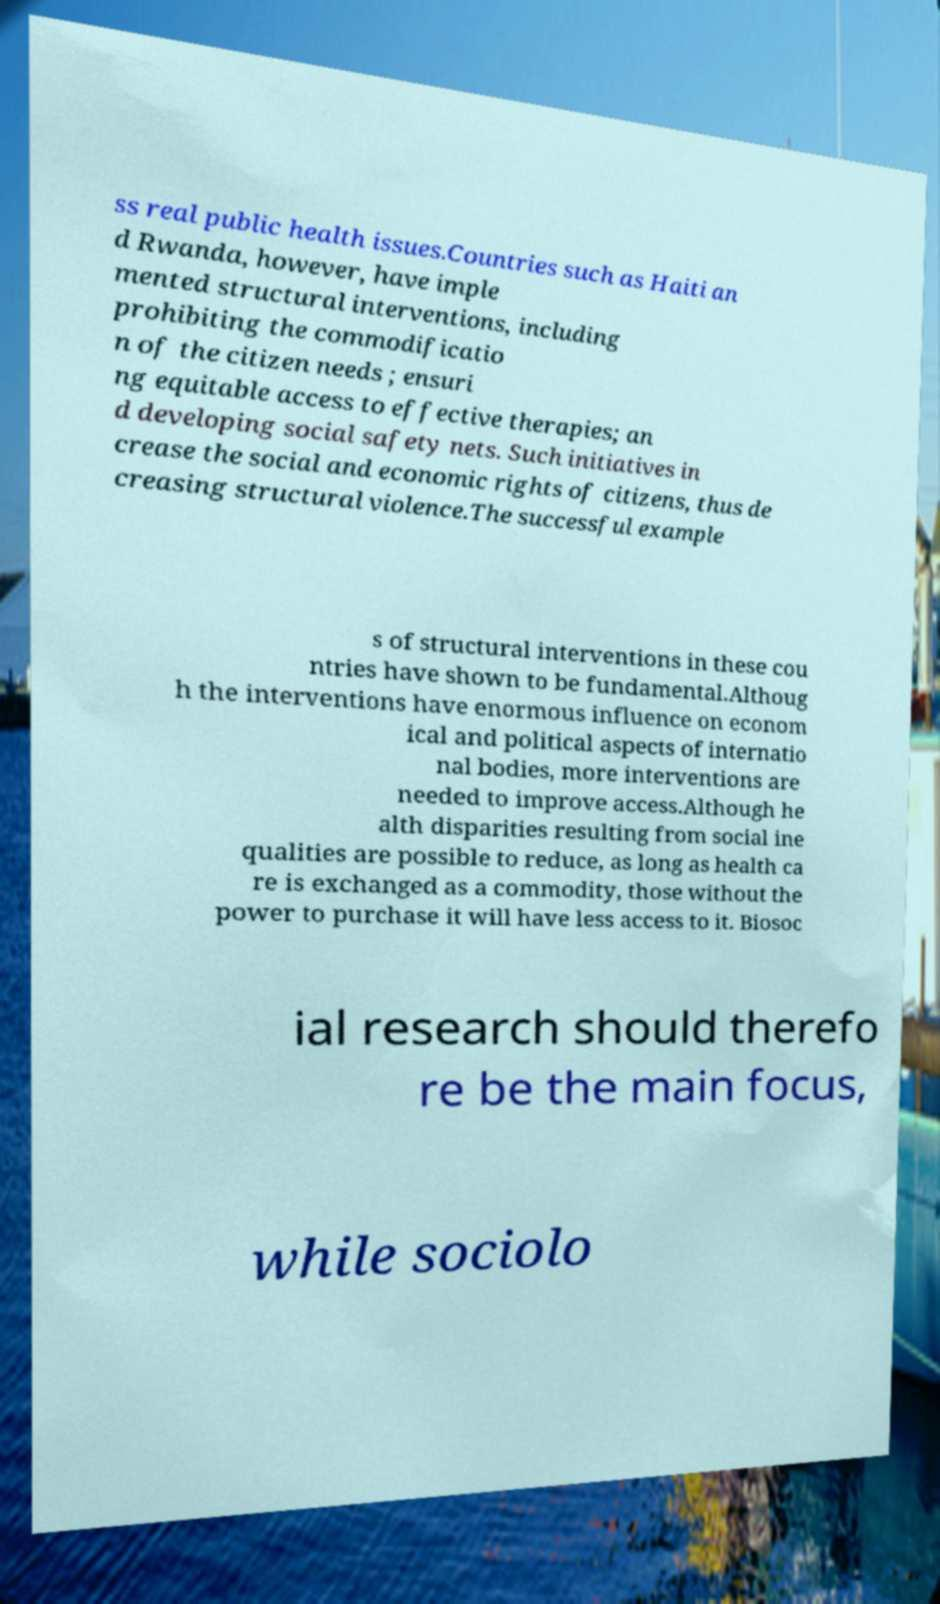There's text embedded in this image that I need extracted. Can you transcribe it verbatim? ss real public health issues.Countries such as Haiti an d Rwanda, however, have imple mented structural interventions, including prohibiting the commodificatio n of the citizen needs ; ensuri ng equitable access to effective therapies; an d developing social safety nets. Such initiatives in crease the social and economic rights of citizens, thus de creasing structural violence.The successful example s of structural interventions in these cou ntries have shown to be fundamental.Althoug h the interventions have enormous influence on econom ical and political aspects of internatio nal bodies, more interventions are needed to improve access.Although he alth disparities resulting from social ine qualities are possible to reduce, as long as health ca re is exchanged as a commodity, those without the power to purchase it will have less access to it. Biosoc ial research should therefo re be the main focus, while sociolo 